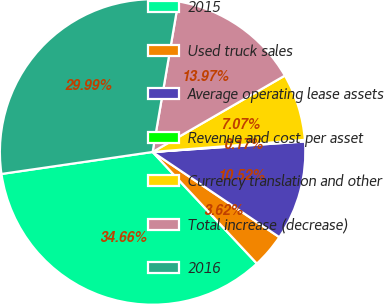Convert chart. <chart><loc_0><loc_0><loc_500><loc_500><pie_chart><fcel>2015<fcel>Used truck sales<fcel>Average operating lease assets<fcel>Revenue and cost per asset<fcel>Currency translation and other<fcel>Total increase (decrease)<fcel>2016<nl><fcel>34.67%<fcel>3.62%<fcel>10.52%<fcel>0.17%<fcel>7.07%<fcel>13.97%<fcel>30.0%<nl></chart> 